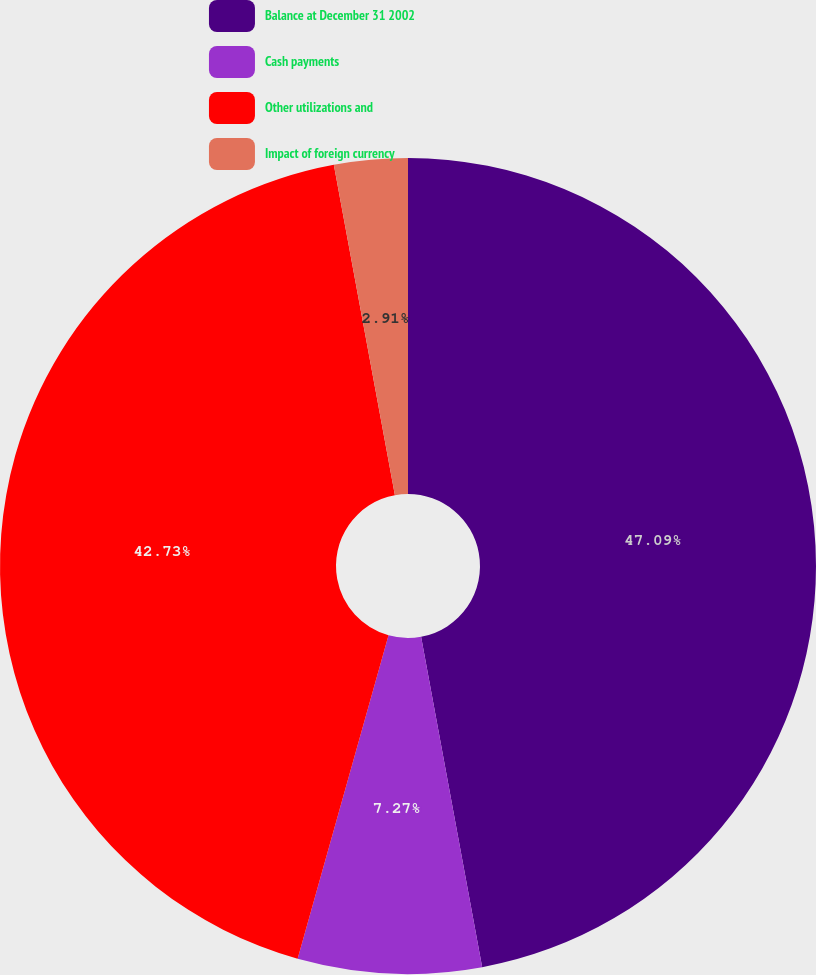Convert chart to OTSL. <chart><loc_0><loc_0><loc_500><loc_500><pie_chart><fcel>Balance at December 31 2002<fcel>Cash payments<fcel>Other utilizations and<fcel>Impact of foreign currency<nl><fcel>47.09%<fcel>7.27%<fcel>42.73%<fcel>2.91%<nl></chart> 